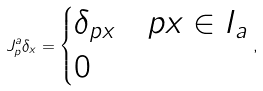<formula> <loc_0><loc_0><loc_500><loc_500>J ^ { a } _ { p } \delta _ { x } = \begin{cases} \delta _ { p x } & p x \in I _ { a } \\ 0 & \end{cases} ,</formula> 